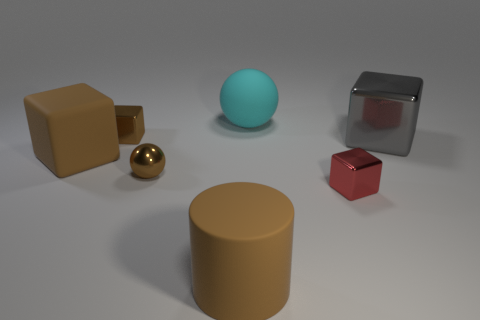There is a tiny thing that is behind the gray cube; does it have the same color as the sphere in front of the large gray object? The small object behind the gray cube is indeed the same color as the sphere in the foreground, both exhibiting a vibrant turquoise hue that distinguishes them from the other objects in the scene. 